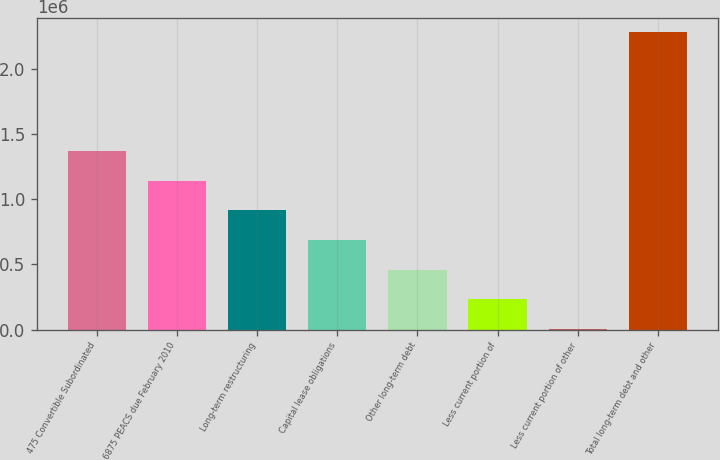<chart> <loc_0><loc_0><loc_500><loc_500><bar_chart><fcel>475 Convertible Subordinated<fcel>6875 PEACS due February 2010<fcel>Long-term restructuring<fcel>Capital lease obligations<fcel>Other long-term debt<fcel>Less current portion of<fcel>Less current portion of other<fcel>Total long-term debt and other<nl><fcel>1.36871e+06<fcel>1.14156e+06<fcel>914410<fcel>687261<fcel>460111<fcel>232962<fcel>5813<fcel>2.2773e+06<nl></chart> 